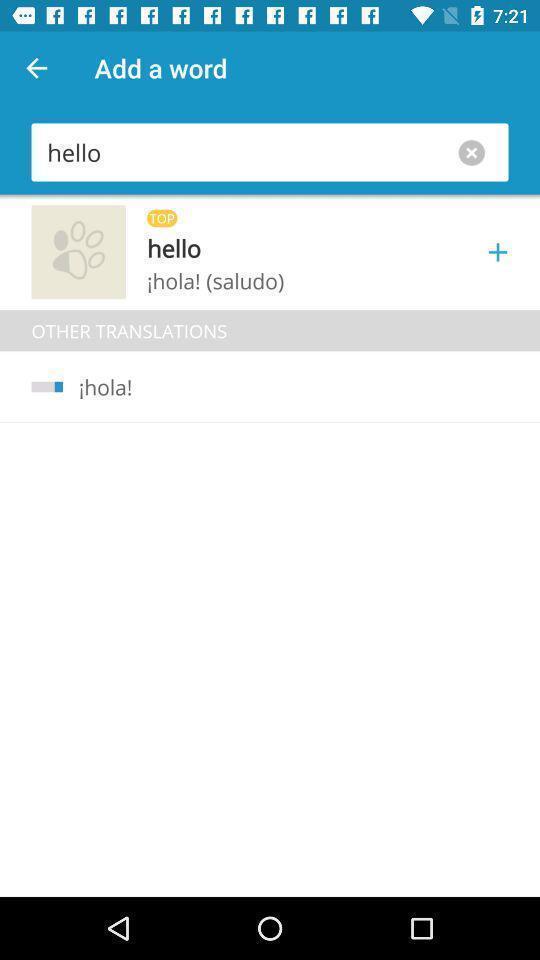Tell me what you see in this picture. Page showing a translation of a hello word. 